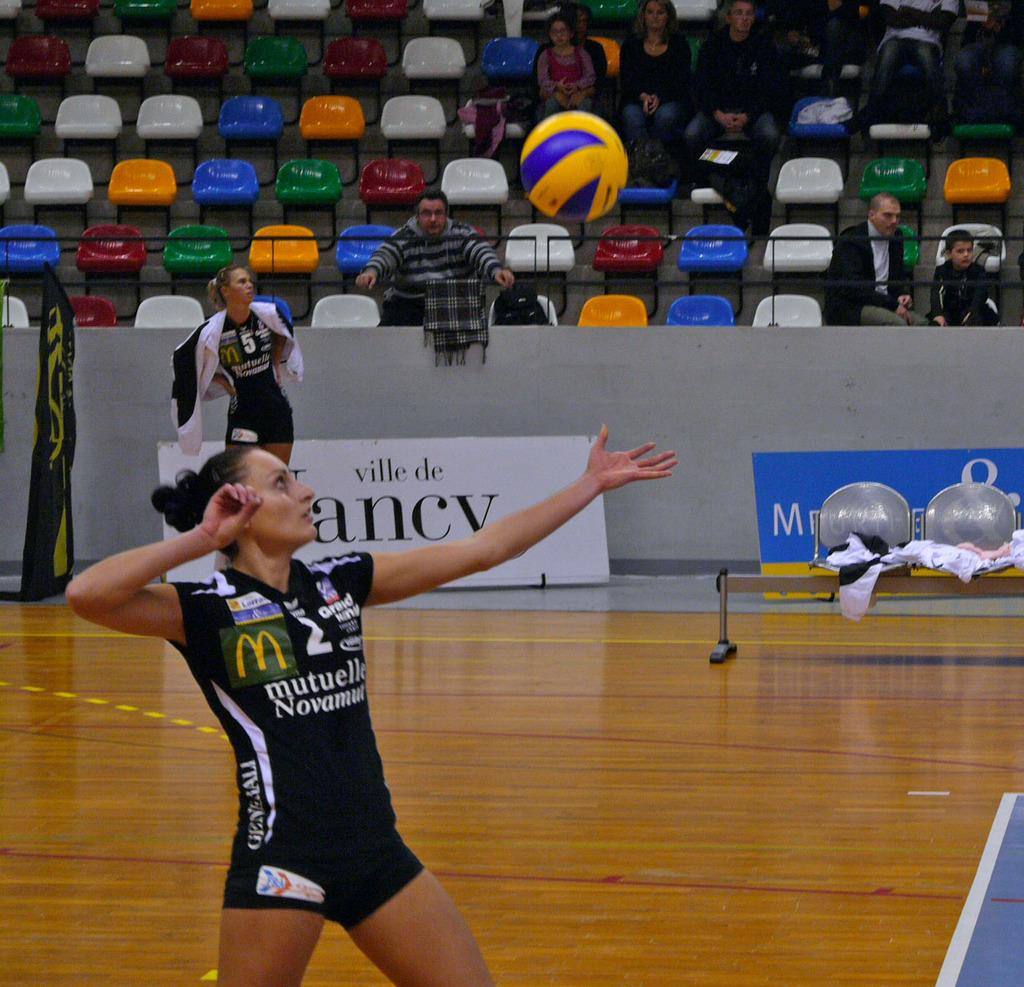<image>
Offer a succinct explanation of the picture presented. Player number 2 is in form to serve the ball as player number 5 watches from the sideline. 